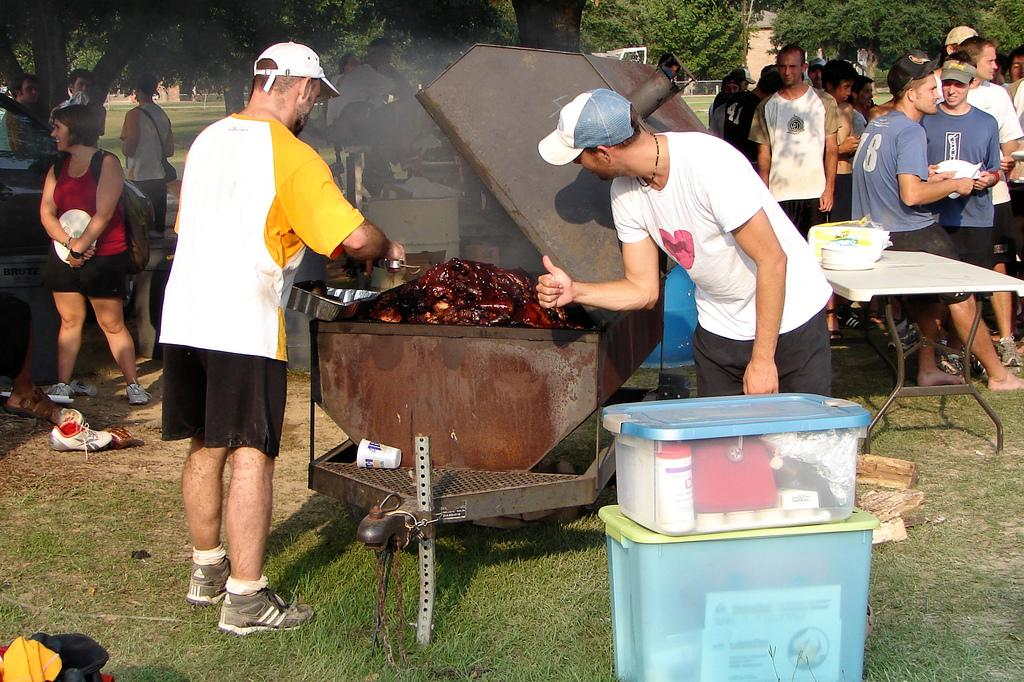<image>
Render a clear and concise summary of the photo. A BBQ where the man cooking has "adidas" written on his shoes. 